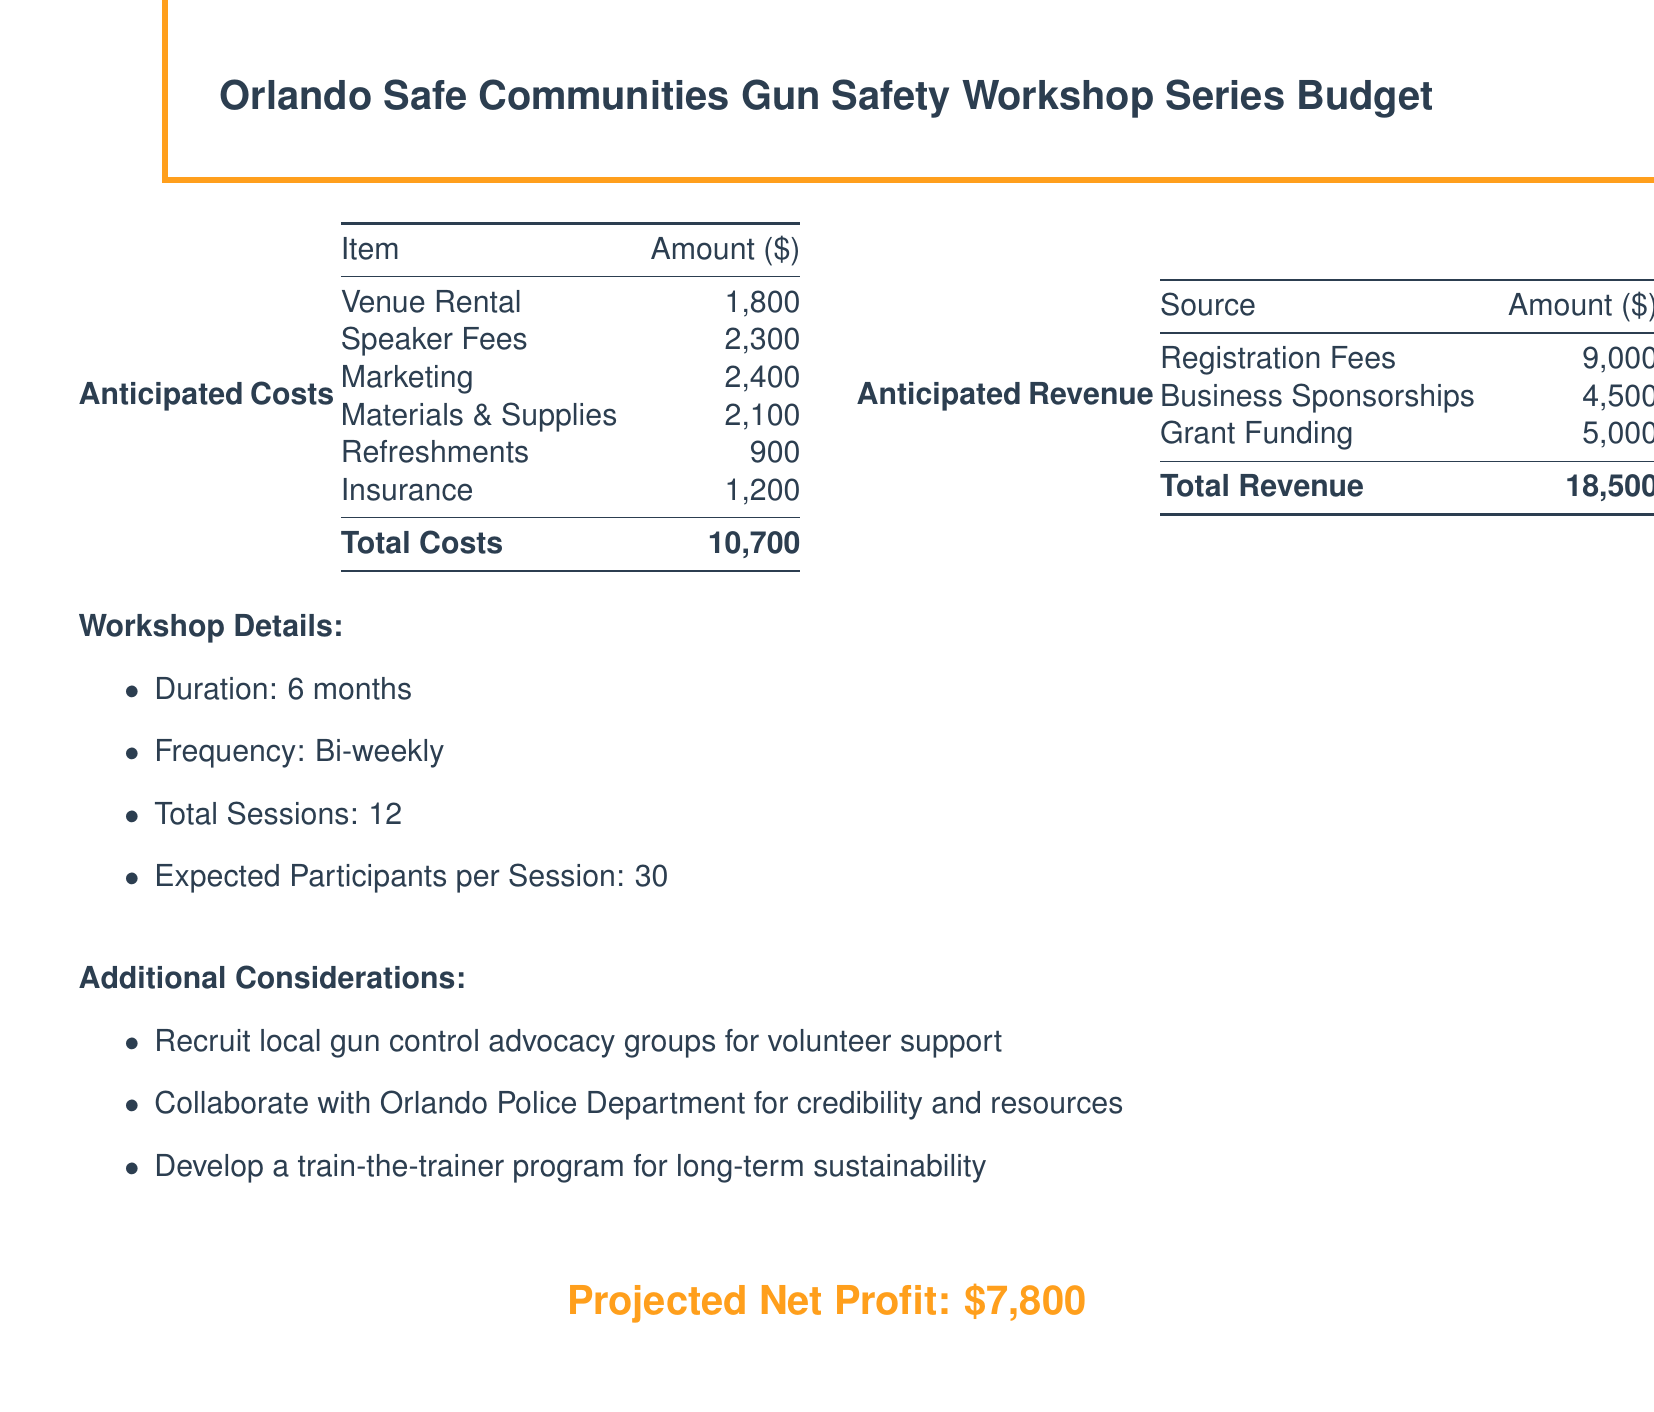what is the total anticipated cost? The total anticipated cost is provided at the end of the anticipated costs section.
Answer: 10,700 what is the amount for speaker fees? The speaker fees amount is listed in the anticipated costs table.
Answer: 2,300 how many total sessions will be held? The total sessions are specified in the workshop details section.
Answer: 12 what is the total revenue expected? The total revenue is provided at the end of the anticipated revenue section.
Answer: 18,500 what is the projected net profit? The projected net profit is stated in the document as a summary at the bottom.
Answer: 7,800 what is the amount for grant funding? The grant funding amount is included in the anticipated revenue table.
Answer: 5,000 how often will the workshops be held? The frequency of the workshops is mentioned in the workshop details section.
Answer: Bi-weekly what is the expected number of participants per session? The expected number of participants per session is indicated under workshop details.
Answer: 30 what is the amount allocated for marketing? The marketing amount is specified in the anticipated costs table.
Answer: 2,400 